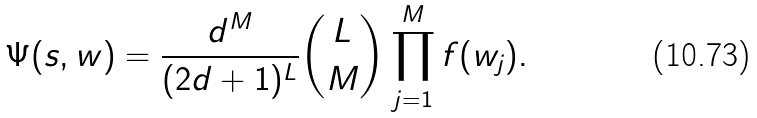Convert formula to latex. <formula><loc_0><loc_0><loc_500><loc_500>\Psi ( s , w ) = \frac { d ^ { M } } { ( 2 d + 1 ) ^ { L } } { L \choose M } \prod _ { j = 1 } ^ { M } f ( w _ { j } ) .</formula> 